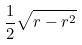<formula> <loc_0><loc_0><loc_500><loc_500>\frac { 1 } { 2 } \sqrt { r - r ^ { 2 } }</formula> 